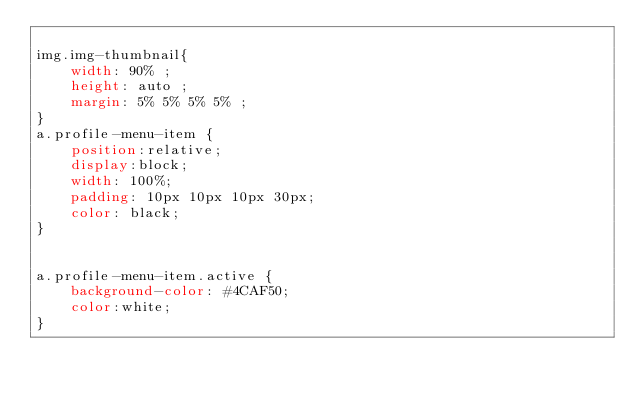<code> <loc_0><loc_0><loc_500><loc_500><_CSS_>
img.img-thumbnail{
    width: 90% ;
    height: auto ;
    margin: 5% 5% 5% 5% ;
}
a.profile-menu-item {
    position:relative;
    display:block;
    width: 100%;
    padding: 10px 10px 10px 30px;
    color: black;
}


a.profile-menu-item.active {
    background-color: #4CAF50;
    color:white;
}

</code> 